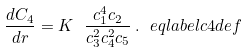Convert formula to latex. <formula><loc_0><loc_0><loc_500><loc_500>\frac { d C _ { 4 } } { d r } = K \ \frac { c _ { 1 } ^ { 4 } c _ { 2 } } { c _ { 3 } ^ { 2 } c _ { 4 } ^ { 2 } c _ { 5 } } \, . \ e q l a b e l { c 4 d e f }</formula> 